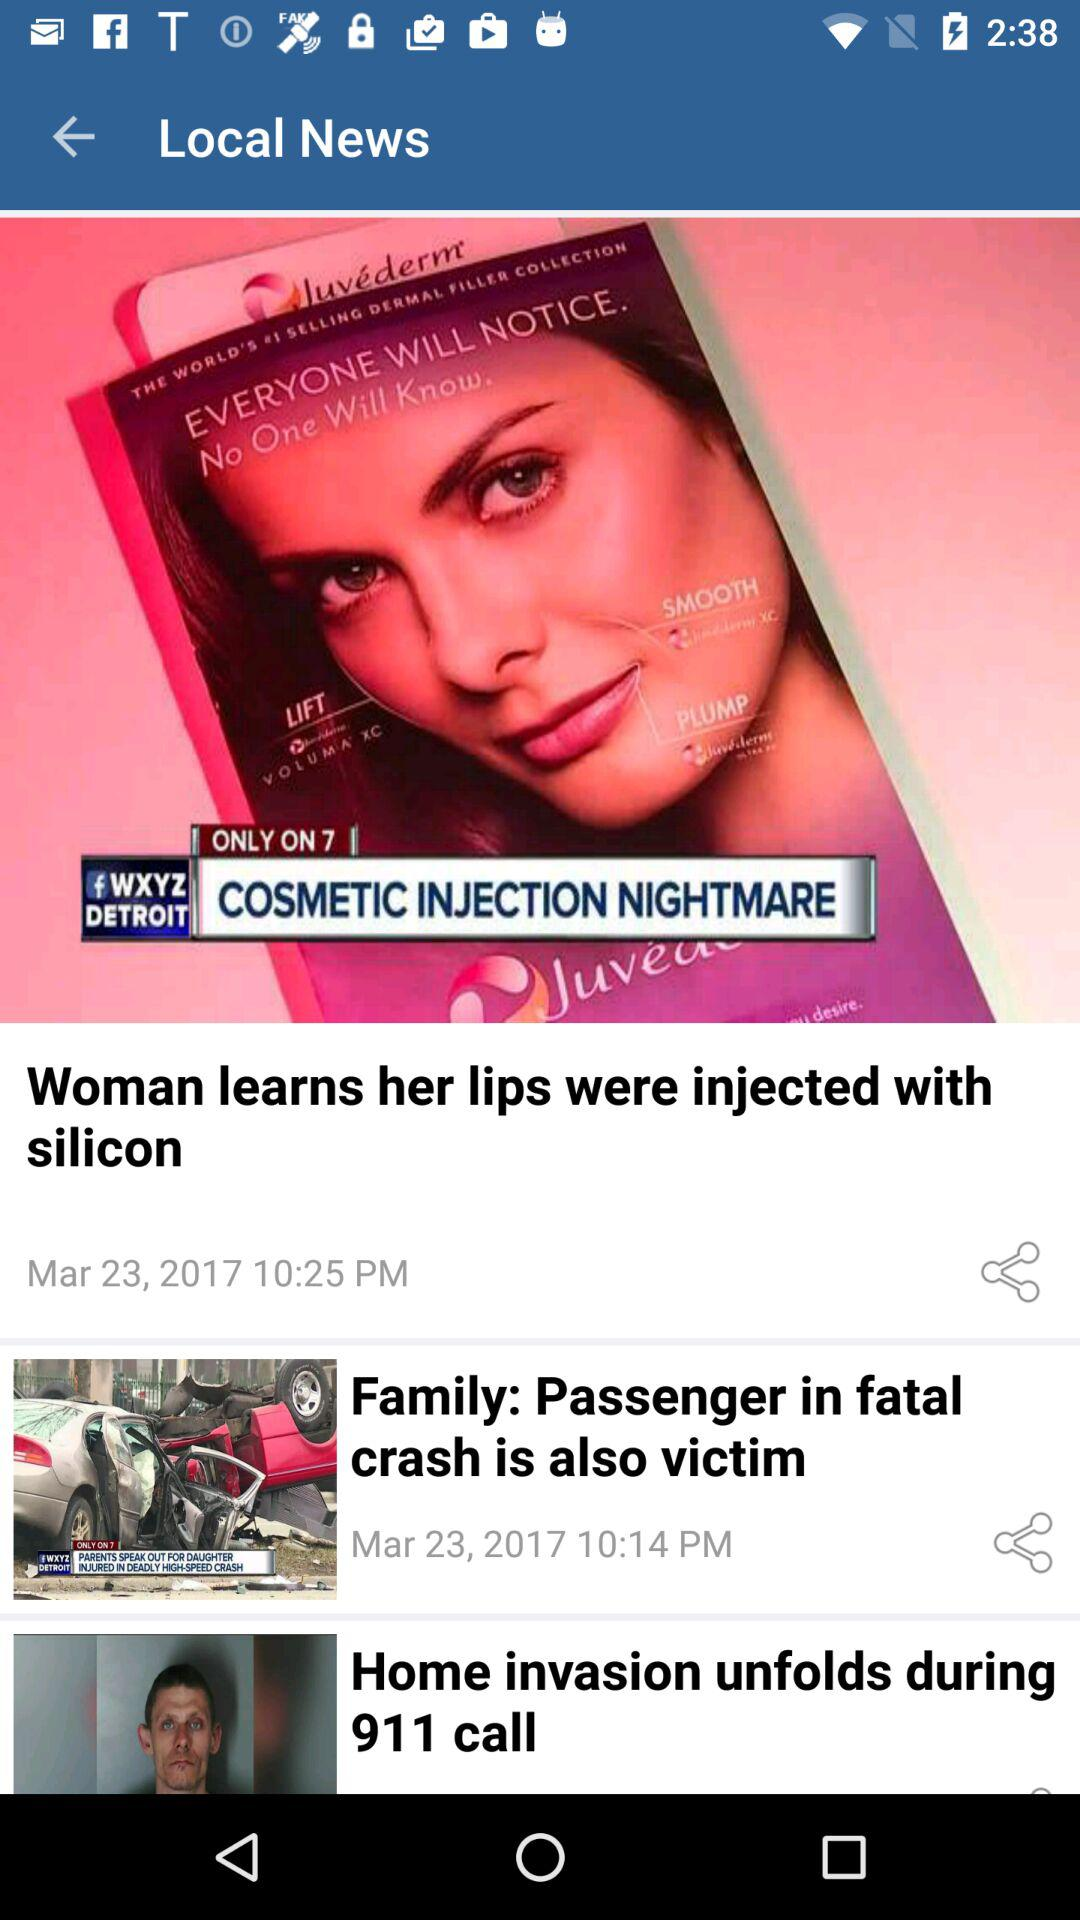How many articles are there?
Answer the question using a single word or phrase. 3 